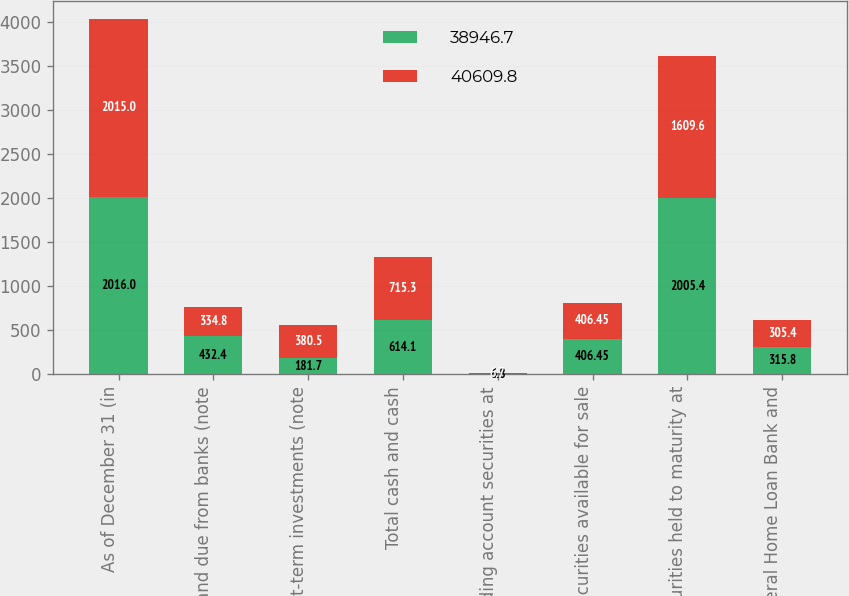Convert chart. <chart><loc_0><loc_0><loc_500><loc_500><stacked_bar_chart><ecel><fcel>As of December 31 (in<fcel>Cash and due from banks (note<fcel>Short-term investments (note<fcel>Total cash and cash<fcel>Trading account securities at<fcel>Securities available for sale<fcel>Securities held to maturity at<fcel>Federal Home Loan Bank and<nl><fcel>38946.7<fcel>2016<fcel>432.4<fcel>181.7<fcel>614.1<fcel>6.8<fcel>406.45<fcel>2005.4<fcel>315.8<nl><fcel>40609.8<fcel>2015<fcel>334.8<fcel>380.5<fcel>715.3<fcel>6.7<fcel>406.45<fcel>1609.6<fcel>305.4<nl></chart> 